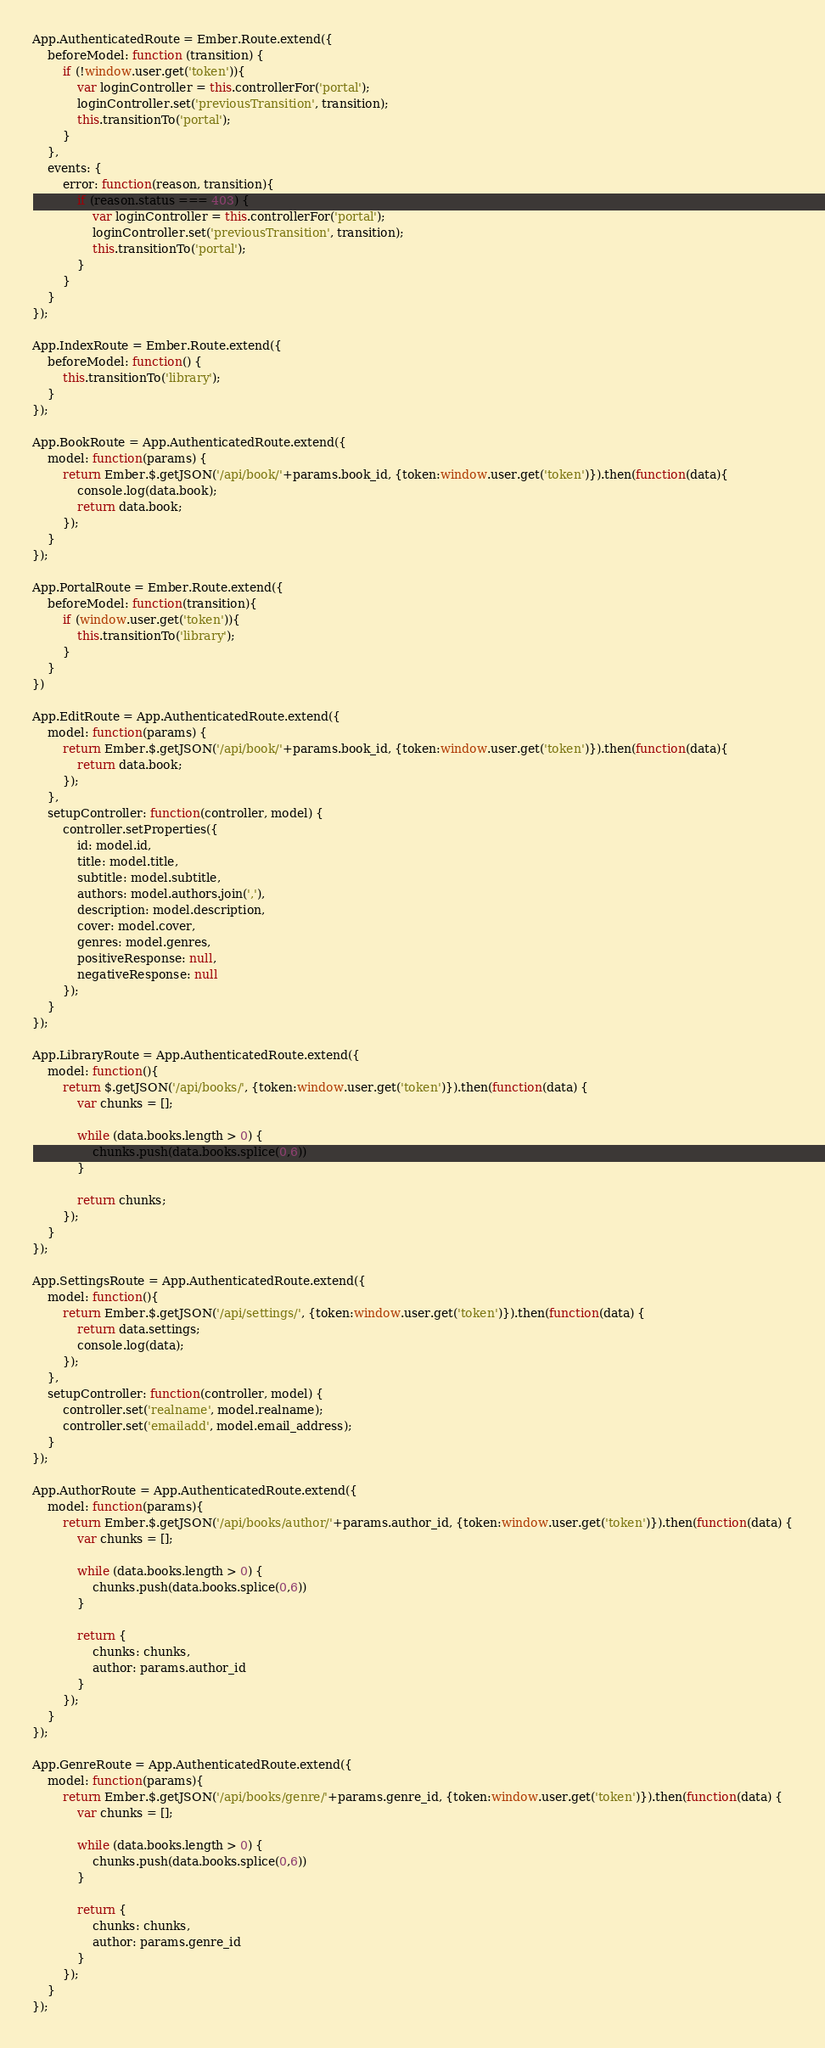Convert code to text. <code><loc_0><loc_0><loc_500><loc_500><_JavaScript_>App.AuthenticatedRoute = Ember.Route.extend({
    beforeModel: function (transition) {
        if (!window.user.get('token')){
            var loginController = this.controllerFor('portal');
            loginController.set('previousTransition', transition);
            this.transitionTo('portal');
        }
    },
    events: {
        error: function(reason, transition){
            if (reason.status === 403) {
                var loginController = this.controllerFor('portal');
                loginController.set('previousTransition', transition);
                this.transitionTo('portal');
            }
        }
    }
});

App.IndexRoute = Ember.Route.extend({
    beforeModel: function() {
        this.transitionTo('library');
    }
});

App.BookRoute = App.AuthenticatedRoute.extend({
    model: function(params) {
        return Ember.$.getJSON('/api/book/'+params.book_id, {token:window.user.get('token')}).then(function(data){
            console.log(data.book);
            return data.book;
        });
    }
});

App.PortalRoute = Ember.Route.extend({
    beforeModel: function(transition){
        if (window.user.get('token')){
            this.transitionTo('library');
        }
    }
})

App.EditRoute = App.AuthenticatedRoute.extend({
    model: function(params) {
        return Ember.$.getJSON('/api/book/'+params.book_id, {token:window.user.get('token')}).then(function(data){
            return data.book;
        });
    },
    setupController: function(controller, model) {
        controller.setProperties({
            id: model.id,
            title: model.title,
            subtitle: model.subtitle,
            authors: model.authors.join(','),
            description: model.description,
            cover: model.cover,
            genres: model.genres,
            positiveResponse: null,
            negativeResponse: null
        });
    }
});

App.LibraryRoute = App.AuthenticatedRoute.extend({
    model: function(){
        return $.getJSON('/api/books/', {token:window.user.get('token')}).then(function(data) {
            var chunks = [];

            while (data.books.length > 0) {
                chunks.push(data.books.splice(0,6))
            }

            return chunks;
        });
    }
});

App.SettingsRoute = App.AuthenticatedRoute.extend({
    model: function(){
        return Ember.$.getJSON('/api/settings/', {token:window.user.get('token')}).then(function(data) {
            return data.settings;
            console.log(data);
        });
    },
    setupController: function(controller, model) {
        controller.set('realname', model.realname);
        controller.set('emailadd', model.email_address);
    }
});

App.AuthorRoute = App.AuthenticatedRoute.extend({
    model: function(params){
        return Ember.$.getJSON('/api/books/author/'+params.author_id, {token:window.user.get('token')}).then(function(data) {
            var chunks = [];

            while (data.books.length > 0) {
                chunks.push(data.books.splice(0,6))
            }

            return {
                chunks: chunks,
                author: params.author_id
            }
        });
    }
});

App.GenreRoute = App.AuthenticatedRoute.extend({
    model: function(params){
        return Ember.$.getJSON('/api/books/genre/'+params.genre_id, {token:window.user.get('token')}).then(function(data) {
            var chunks = [];

            while (data.books.length > 0) {
                chunks.push(data.books.splice(0,6))
            }

            return {
                chunks: chunks,
                author: params.genre_id
            }
        });
    }
});
</code> 